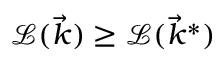<formula> <loc_0><loc_0><loc_500><loc_500>\mathcal { L } ( \vec { k } ) \geq \mathcal { L } ( \vec { k } ^ { * } )</formula> 